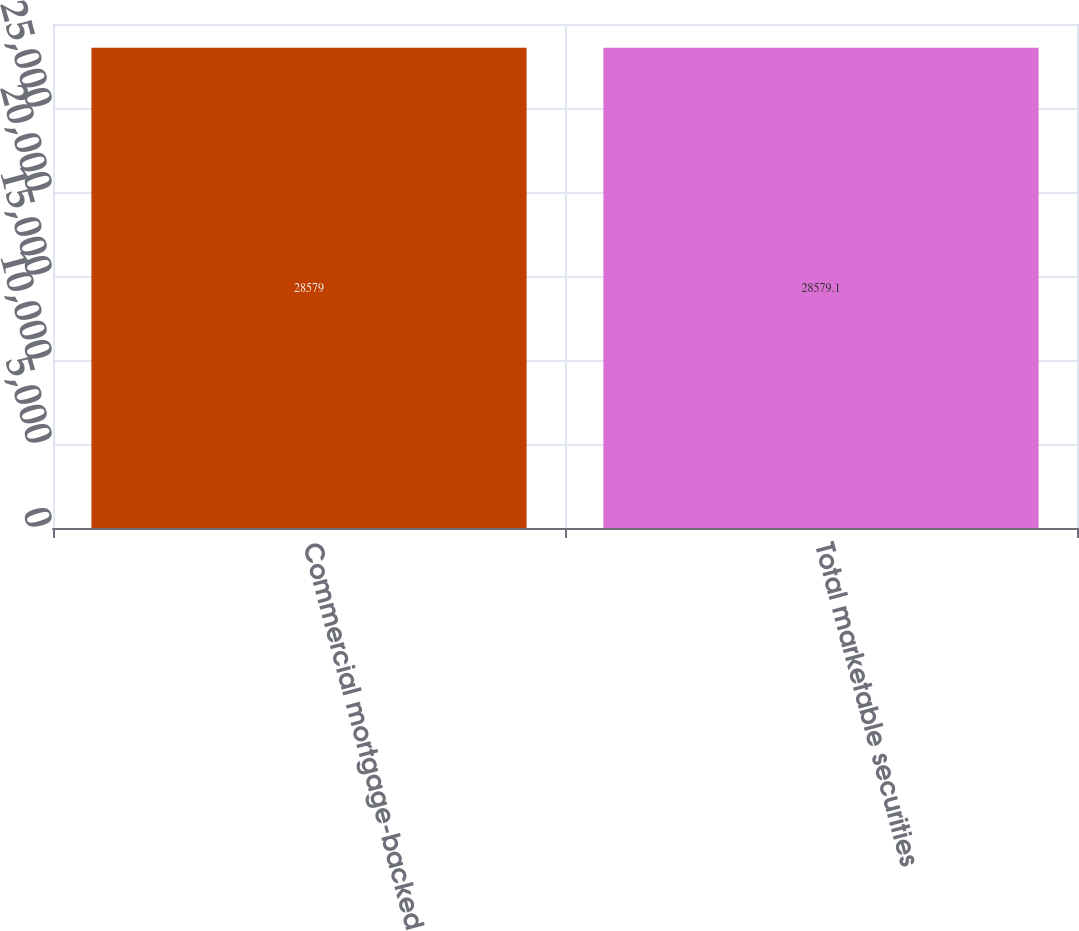Convert chart. <chart><loc_0><loc_0><loc_500><loc_500><bar_chart><fcel>Commercial mortgage-backed<fcel>Total marketable securities<nl><fcel>28579<fcel>28579.1<nl></chart> 